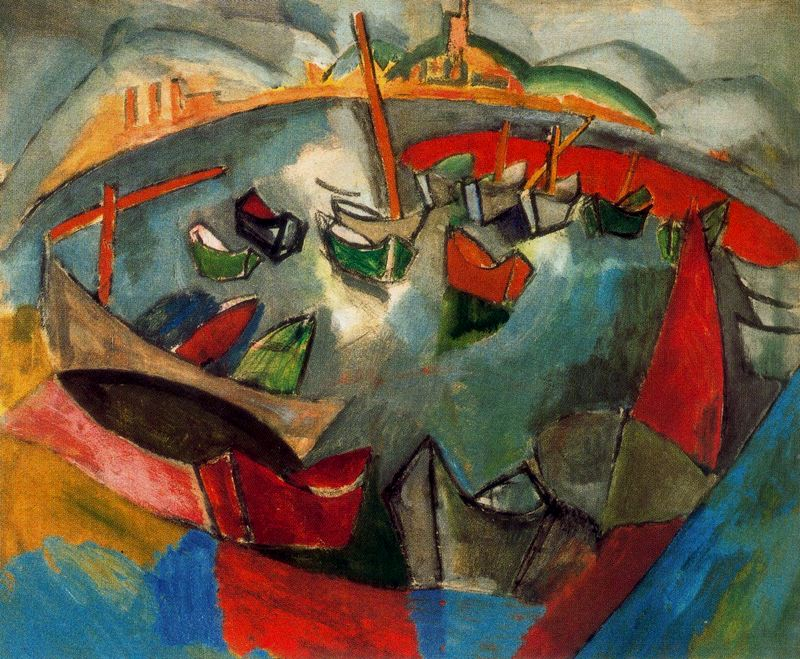What is this photo about? The image is a striking example of post-impressionist art, depicting a bustling harbor scene. The artwork captures an array of boats, each painted with bold, exaggerated forms that merge into an energetic ensemble of colors. The use of distorted shapes and a vibrant palette of blues, greens, oranges, and reds adds a lively, almost chaotic quality, reflecting the dynamic nature of life at the harbor. This artistic approach not only emphasizes the physical movement but also evokes the emotional vibrancy found in such a lively communal space. 